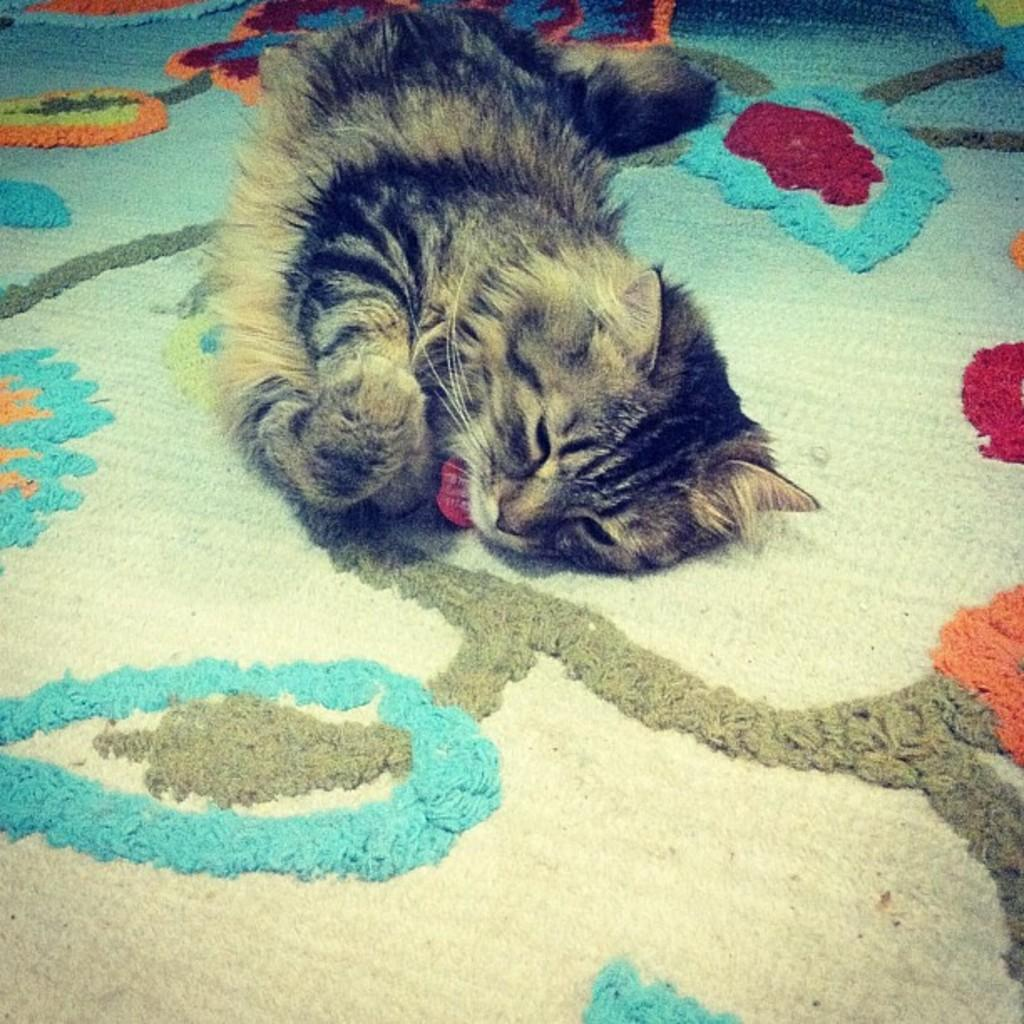What type of animal is in the image? There is a cat in the image. What is the cat doing in the image? The cat is laying down. What type of hose is the cat using to attempt a new position in the image? There is no hose present in the image, and the cat is not attempting any new positions. 